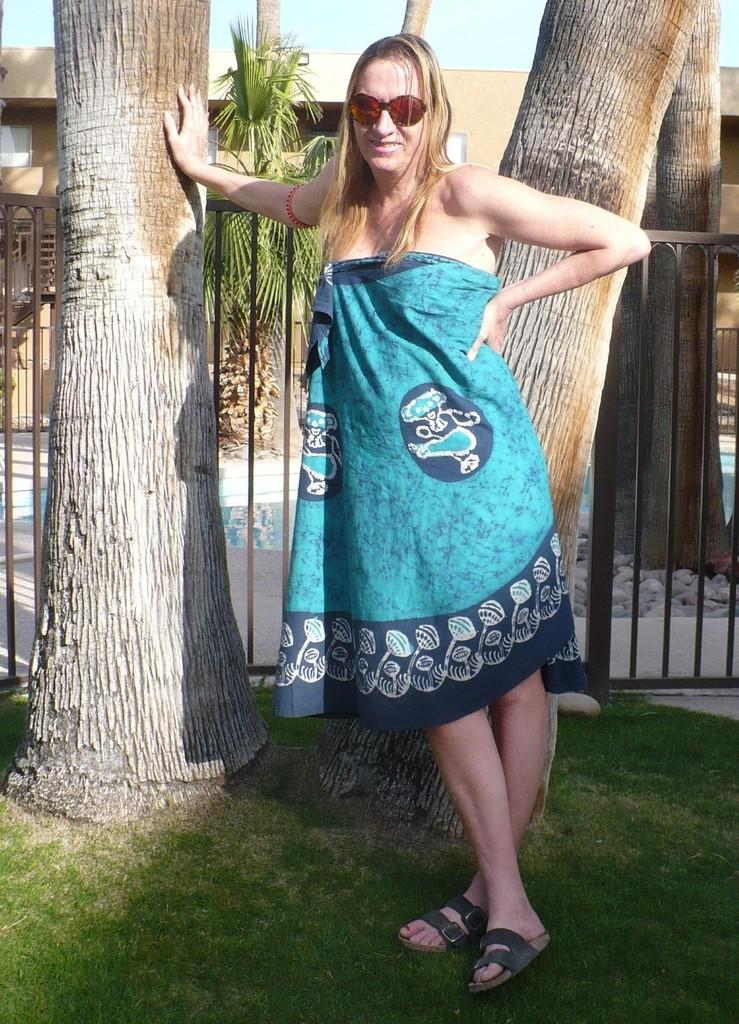Who is present in the image? There is a woman in the image. What is the woman wearing? The woman is wearing a blue dress. What can be seen in the background of the image? There are trees, a building, and the sky visible in the background of the image. What type of terrain is at the bottom of the image? There is grass at the bottom of the image. What type of bread is being used as a weapon in the battle depicted in the image? There is no battle or bread present in the image; it features a woman in a blue dress with a background of trees, a building, grass, and the sky. 